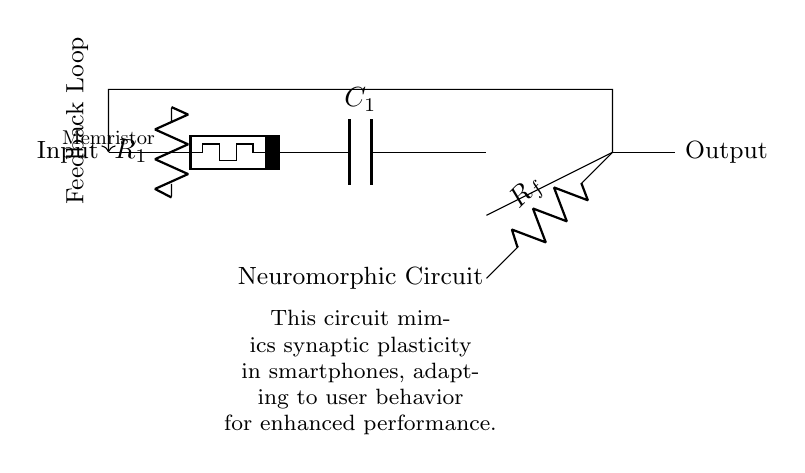What is the main type of circuit represented? The primary type of circuit represented is a neuromorphic circuit, which is designed to mimic the functioning of biological neural networks. The terminology "neuromorphic" suggests that it has been engineered to replicate the properties seen in neurological systems, particularly synaptic plasticity.
Answer: neuromorphic circuit What component is used to simulate the synapse? The circuit includes a memristor, which is positioned as the synaptic element. Memristors are unique because they can vary their resistance based on the history of voltage and current that has passed through them, thus effectively mimicking synaptic plasticity in biological systems.
Answer: memristor How many resistors are present in the circuit? There are two resistors in the circuit, one labeled R1 and the other Rf. The presence of multiple resistors typically indicates that various parts of the circuit control and regulate the current flowing through different sections.
Answer: two What feedback mechanism is illustrated? The circuit shows a feedback loop as indicated by the arrow returning from the output back to the input. Feedback loops are essential in neuromorphic circuits as they allow the system to adapt based on the output results, enhancing learning and performance over time.
Answer: feedback loop What is the purpose of the capacitor in this circuit? The capacitor, labeled C1, functions to store charge temporarily, which is vital in smoothing out variations in output voltage and timing elements in the neuromorphic circuit. Capacitors help maintain stable operation by managing transient behavior in electrical circuits.
Answer: charge storage What condition does the operational amplifier fulfill here? The operational amplifier, or op amp, amplifies the voltage differences between its input terminals, facilitating signal processing in the circuit. It enables stronger output signals which can be crucial for the performance of neural circuit functions, such as information processing.
Answer: signal amplification How does this circuit adapt to user behavior? The circuit adapts through synaptic plasticity, controlled by the memristor's changing resistance according to user input patterns. As the device interacts with the user, it develops and strengthens synaptic pathways to improve efficiency based on learned behaviors, much like a biological system.
Answer: synaptic plasticity 